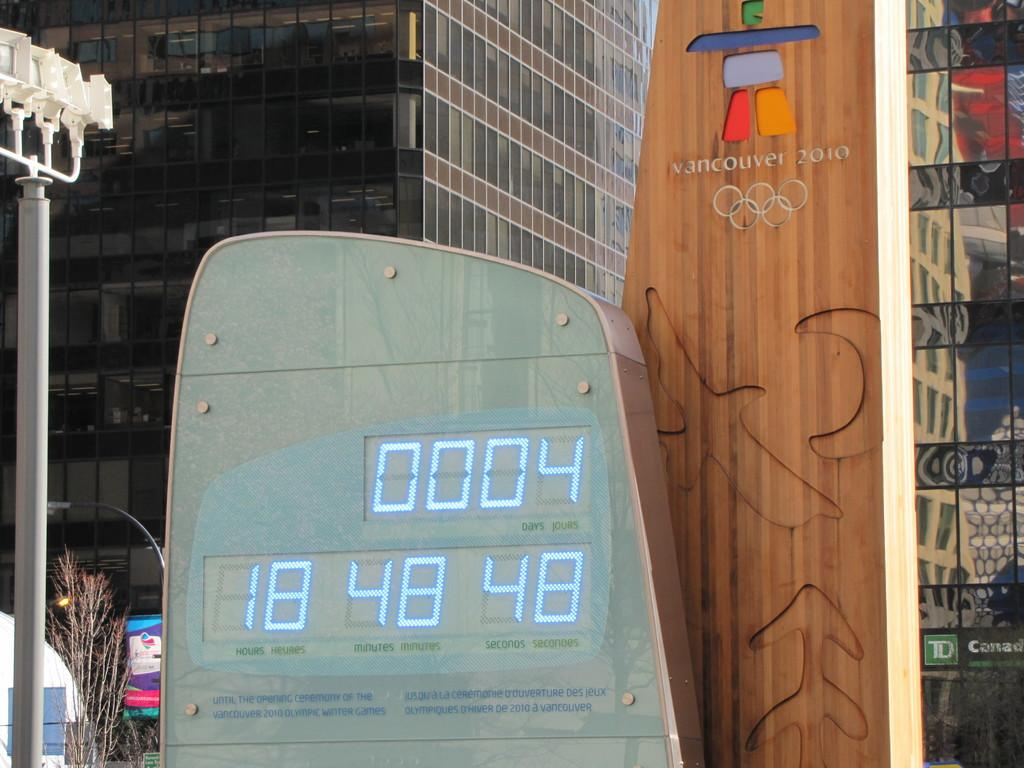What type of signage can be seen in the image? There are hoardings in the image. What type of structures are visible in the image? There are buildings in the image. What type of vegetation is present in the image? There are plants in the image. What type of vertical structure can be seen in the image? There is a pole in the image. What type of illumination is present in the image? There are lights in the image. What type of transportation is visible in the image? There is a vehicle in the image. What advice does the governor give to the stranger in the image? There is no governor or stranger present in the image, so no such interaction can be observed. What type of things are being sold in the image? The provided facts do not mention any items being sold in the image. 